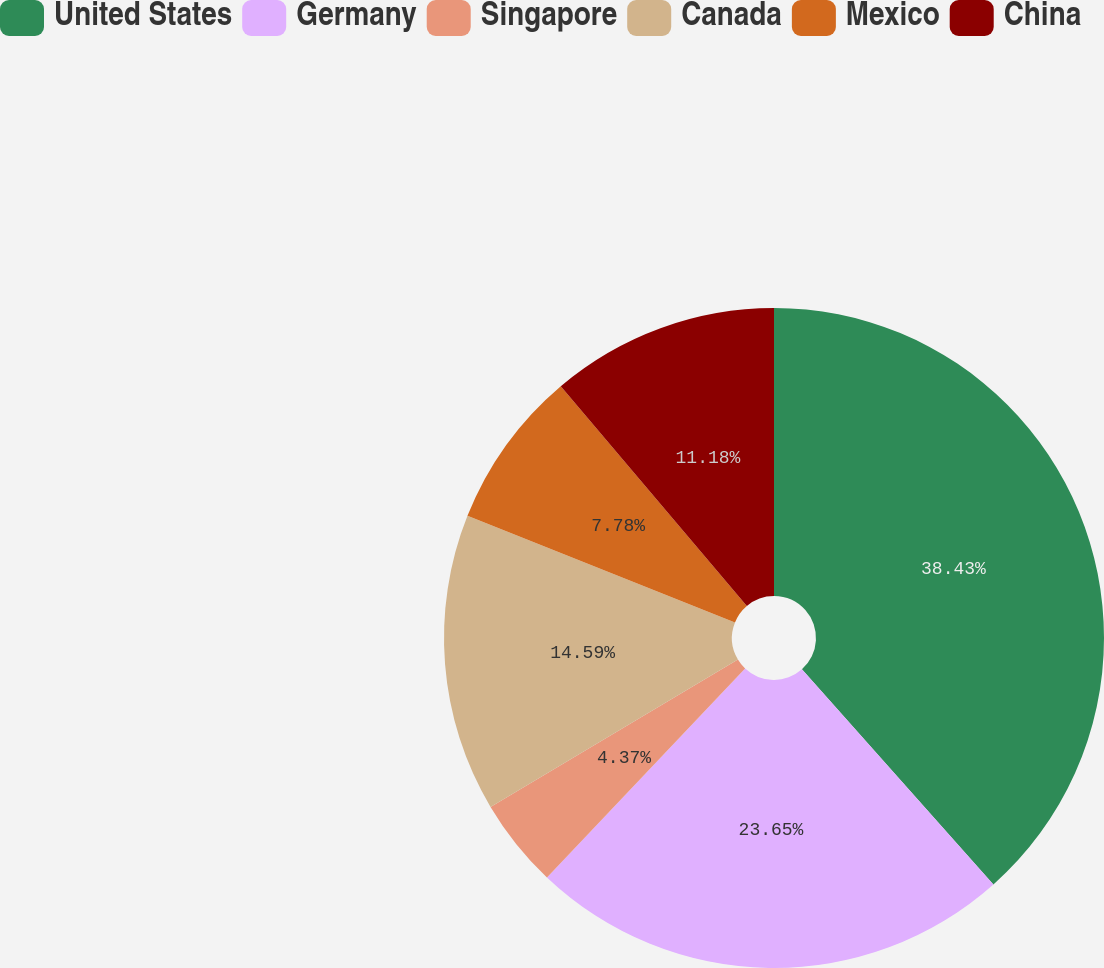Convert chart. <chart><loc_0><loc_0><loc_500><loc_500><pie_chart><fcel>United States<fcel>Germany<fcel>Singapore<fcel>Canada<fcel>Mexico<fcel>China<nl><fcel>38.42%<fcel>23.65%<fcel>4.37%<fcel>14.59%<fcel>7.78%<fcel>11.18%<nl></chart> 